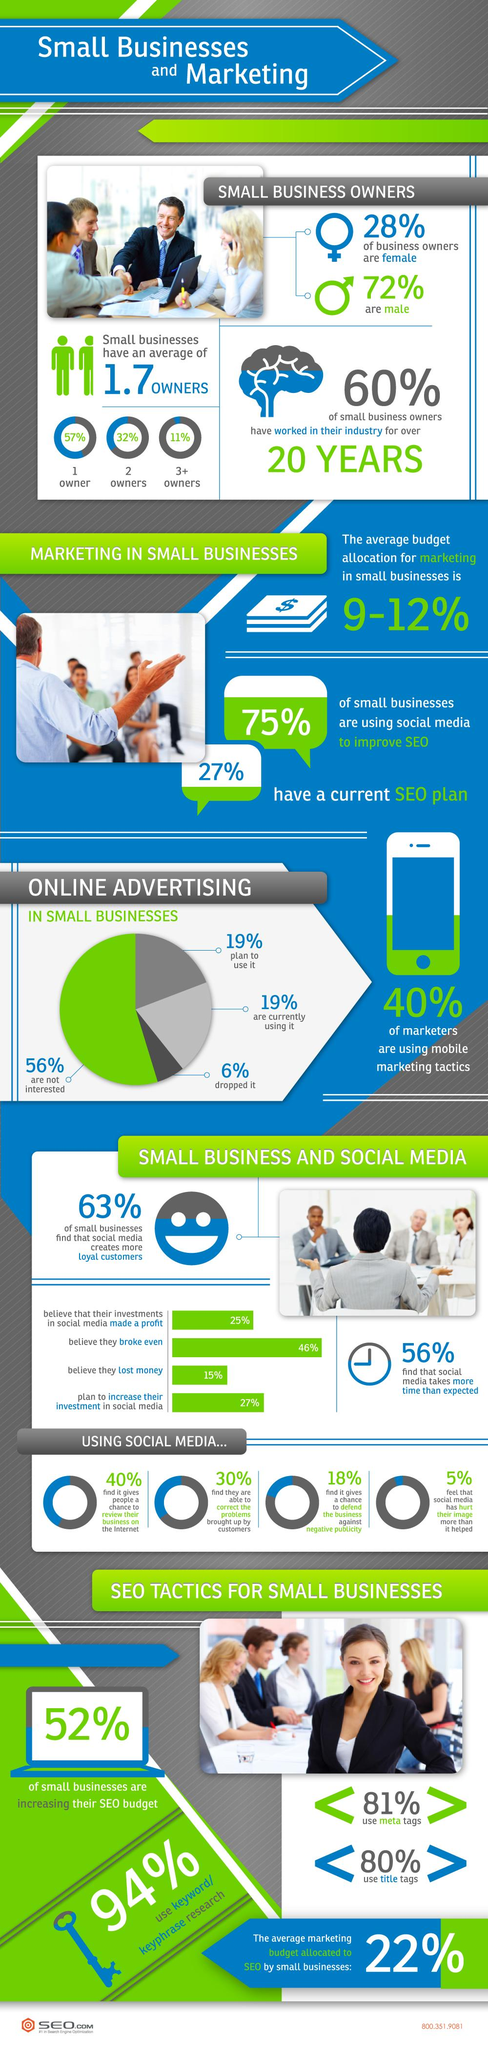Indicate a few pertinent items in this graphic. According to a survey, 25% of small businesses do not use social media to improve their SEO. Nearly 56% of people are not interested in online advertising. Approximately 27% of businesses use SEO for marketing. According to the given information, 46% of people neither made a profit nor a loss. Maximum small businesses have one owner. 